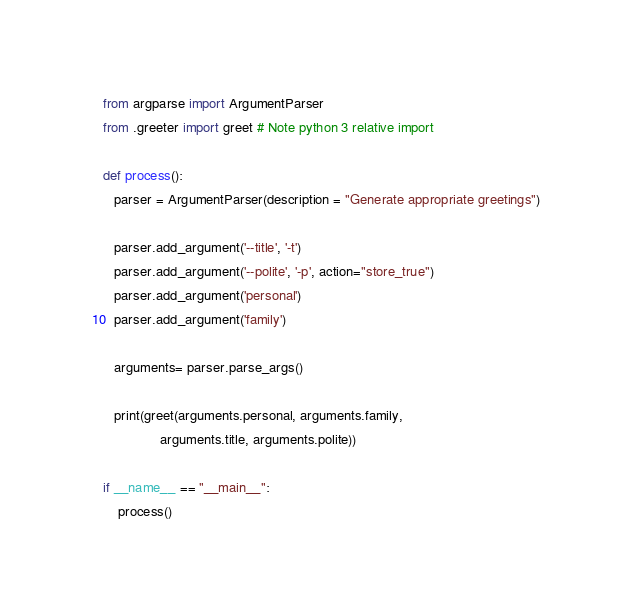<code> <loc_0><loc_0><loc_500><loc_500><_Python_>from argparse import ArgumentParser
from .greeter import greet # Note python 3 relative import

def process():
   parser = ArgumentParser(description = "Generate appropriate greetings")

   parser.add_argument('--title', '-t')
   parser.add_argument('--polite', '-p', action="store_true")
   parser.add_argument('personal')
   parser.add_argument('family')

   arguments= parser.parse_args()

   print(greet(arguments.personal, arguments.family, 
               arguments.title, arguments.polite))

if __name__ == "__main__":
    process()
</code> 